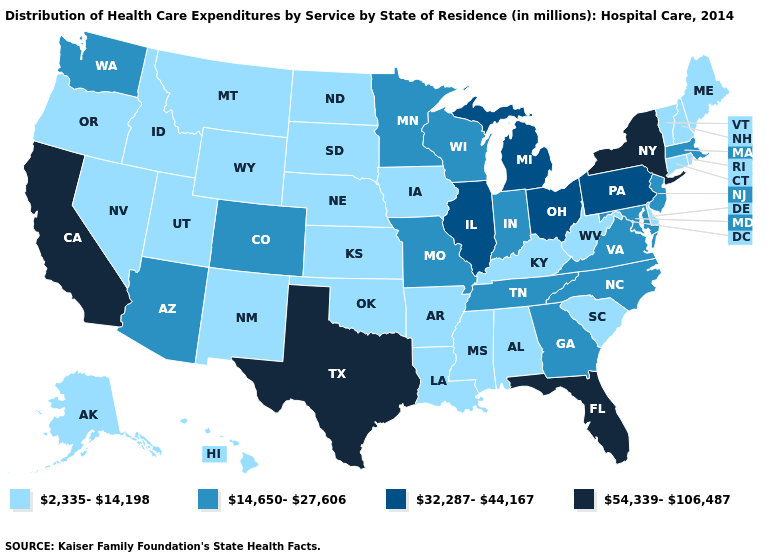What is the value of South Carolina?
Concise answer only. 2,335-14,198. What is the value of Iowa?
Concise answer only. 2,335-14,198. Is the legend a continuous bar?
Short answer required. No. Which states have the highest value in the USA?
Give a very brief answer. California, Florida, New York, Texas. What is the lowest value in the USA?
Short answer required. 2,335-14,198. Among the states that border Kansas , does Oklahoma have the highest value?
Concise answer only. No. Which states have the highest value in the USA?
Concise answer only. California, Florida, New York, Texas. What is the highest value in the Northeast ?
Be succinct. 54,339-106,487. Among the states that border Colorado , does Wyoming have the lowest value?
Concise answer only. Yes. Does Minnesota have a higher value than North Carolina?
Keep it brief. No. Name the states that have a value in the range 32,287-44,167?
Write a very short answer. Illinois, Michigan, Ohio, Pennsylvania. Among the states that border Delaware , does New Jersey have the highest value?
Quick response, please. No. Name the states that have a value in the range 32,287-44,167?
Be succinct. Illinois, Michigan, Ohio, Pennsylvania. What is the value of Georgia?
Write a very short answer. 14,650-27,606. Name the states that have a value in the range 2,335-14,198?
Be succinct. Alabama, Alaska, Arkansas, Connecticut, Delaware, Hawaii, Idaho, Iowa, Kansas, Kentucky, Louisiana, Maine, Mississippi, Montana, Nebraska, Nevada, New Hampshire, New Mexico, North Dakota, Oklahoma, Oregon, Rhode Island, South Carolina, South Dakota, Utah, Vermont, West Virginia, Wyoming. 